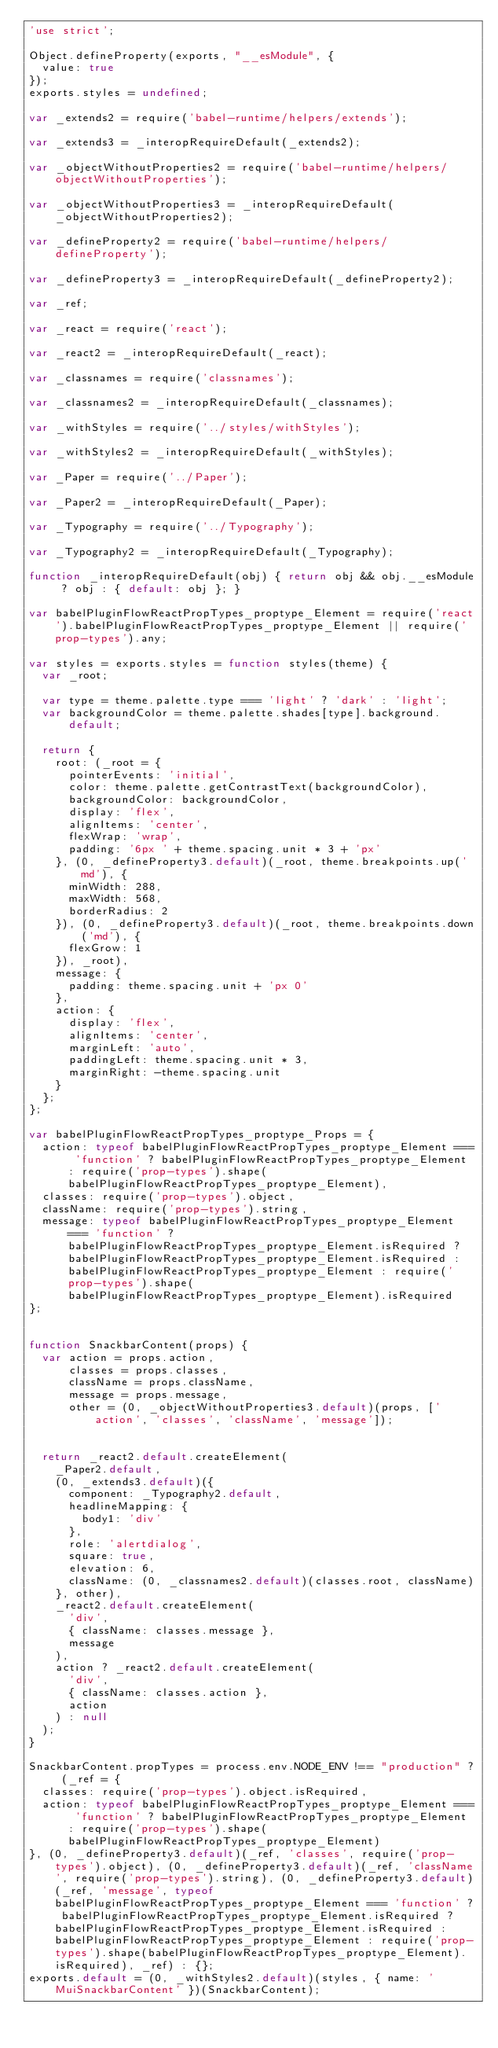<code> <loc_0><loc_0><loc_500><loc_500><_JavaScript_>'use strict';

Object.defineProperty(exports, "__esModule", {
  value: true
});
exports.styles = undefined;

var _extends2 = require('babel-runtime/helpers/extends');

var _extends3 = _interopRequireDefault(_extends2);

var _objectWithoutProperties2 = require('babel-runtime/helpers/objectWithoutProperties');

var _objectWithoutProperties3 = _interopRequireDefault(_objectWithoutProperties2);

var _defineProperty2 = require('babel-runtime/helpers/defineProperty');

var _defineProperty3 = _interopRequireDefault(_defineProperty2);

var _ref;

var _react = require('react');

var _react2 = _interopRequireDefault(_react);

var _classnames = require('classnames');

var _classnames2 = _interopRequireDefault(_classnames);

var _withStyles = require('../styles/withStyles');

var _withStyles2 = _interopRequireDefault(_withStyles);

var _Paper = require('../Paper');

var _Paper2 = _interopRequireDefault(_Paper);

var _Typography = require('../Typography');

var _Typography2 = _interopRequireDefault(_Typography);

function _interopRequireDefault(obj) { return obj && obj.__esModule ? obj : { default: obj }; }

var babelPluginFlowReactPropTypes_proptype_Element = require('react').babelPluginFlowReactPropTypes_proptype_Element || require('prop-types').any;

var styles = exports.styles = function styles(theme) {
  var _root;

  var type = theme.palette.type === 'light' ? 'dark' : 'light';
  var backgroundColor = theme.palette.shades[type].background.default;

  return {
    root: (_root = {
      pointerEvents: 'initial',
      color: theme.palette.getContrastText(backgroundColor),
      backgroundColor: backgroundColor,
      display: 'flex',
      alignItems: 'center',
      flexWrap: 'wrap',
      padding: '6px ' + theme.spacing.unit * 3 + 'px'
    }, (0, _defineProperty3.default)(_root, theme.breakpoints.up('md'), {
      minWidth: 288,
      maxWidth: 568,
      borderRadius: 2
    }), (0, _defineProperty3.default)(_root, theme.breakpoints.down('md'), {
      flexGrow: 1
    }), _root),
    message: {
      padding: theme.spacing.unit + 'px 0'
    },
    action: {
      display: 'flex',
      alignItems: 'center',
      marginLeft: 'auto',
      paddingLeft: theme.spacing.unit * 3,
      marginRight: -theme.spacing.unit
    }
  };
};

var babelPluginFlowReactPropTypes_proptype_Props = {
  action: typeof babelPluginFlowReactPropTypes_proptype_Element === 'function' ? babelPluginFlowReactPropTypes_proptype_Element : require('prop-types').shape(babelPluginFlowReactPropTypes_proptype_Element),
  classes: require('prop-types').object,
  className: require('prop-types').string,
  message: typeof babelPluginFlowReactPropTypes_proptype_Element === 'function' ? babelPluginFlowReactPropTypes_proptype_Element.isRequired ? babelPluginFlowReactPropTypes_proptype_Element.isRequired : babelPluginFlowReactPropTypes_proptype_Element : require('prop-types').shape(babelPluginFlowReactPropTypes_proptype_Element).isRequired
};


function SnackbarContent(props) {
  var action = props.action,
      classes = props.classes,
      className = props.className,
      message = props.message,
      other = (0, _objectWithoutProperties3.default)(props, ['action', 'classes', 'className', 'message']);


  return _react2.default.createElement(
    _Paper2.default,
    (0, _extends3.default)({
      component: _Typography2.default,
      headlineMapping: {
        body1: 'div'
      },
      role: 'alertdialog',
      square: true,
      elevation: 6,
      className: (0, _classnames2.default)(classes.root, className)
    }, other),
    _react2.default.createElement(
      'div',
      { className: classes.message },
      message
    ),
    action ? _react2.default.createElement(
      'div',
      { className: classes.action },
      action
    ) : null
  );
}

SnackbarContent.propTypes = process.env.NODE_ENV !== "production" ? (_ref = {
  classes: require('prop-types').object.isRequired,
  action: typeof babelPluginFlowReactPropTypes_proptype_Element === 'function' ? babelPluginFlowReactPropTypes_proptype_Element : require('prop-types').shape(babelPluginFlowReactPropTypes_proptype_Element)
}, (0, _defineProperty3.default)(_ref, 'classes', require('prop-types').object), (0, _defineProperty3.default)(_ref, 'className', require('prop-types').string), (0, _defineProperty3.default)(_ref, 'message', typeof babelPluginFlowReactPropTypes_proptype_Element === 'function' ? babelPluginFlowReactPropTypes_proptype_Element.isRequired ? babelPluginFlowReactPropTypes_proptype_Element.isRequired : babelPluginFlowReactPropTypes_proptype_Element : require('prop-types').shape(babelPluginFlowReactPropTypes_proptype_Element).isRequired), _ref) : {};
exports.default = (0, _withStyles2.default)(styles, { name: 'MuiSnackbarContent' })(SnackbarContent);</code> 